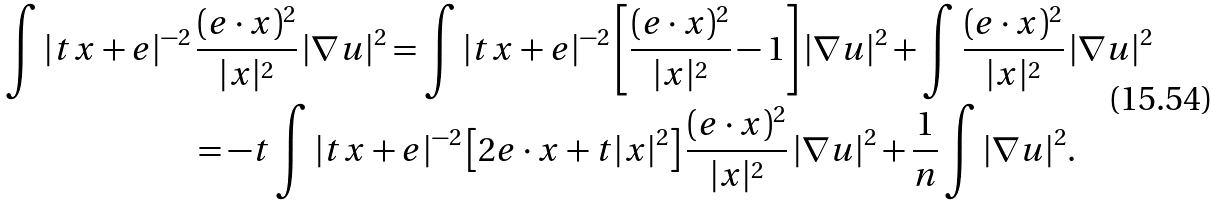<formula> <loc_0><loc_0><loc_500><loc_500>\int | t x + e | ^ { - 2 } & \, \frac { ( e \cdot x ) ^ { 2 } } { | x | ^ { 2 } } \, | \nabla u | ^ { 2 } = \int | t x + e | ^ { - 2 } \left [ \frac { ( e \cdot x ) ^ { 2 } } { | x | ^ { 2 } } - 1 \right ] | \nabla u | ^ { 2 } + \int \frac { ( e \cdot x ) ^ { 2 } } { | x | ^ { 2 } } \, | \nabla u | ^ { 2 } \\ & = - t \int | t x + e | ^ { - 2 } \left [ 2 e \cdot x + t | x | ^ { 2 } \right ] \frac { ( e \cdot x ) ^ { 2 } } { | x | ^ { 2 } } \, | \nabla u | ^ { 2 } + \frac { 1 } { n } \int | \nabla u | ^ { 2 } .</formula> 